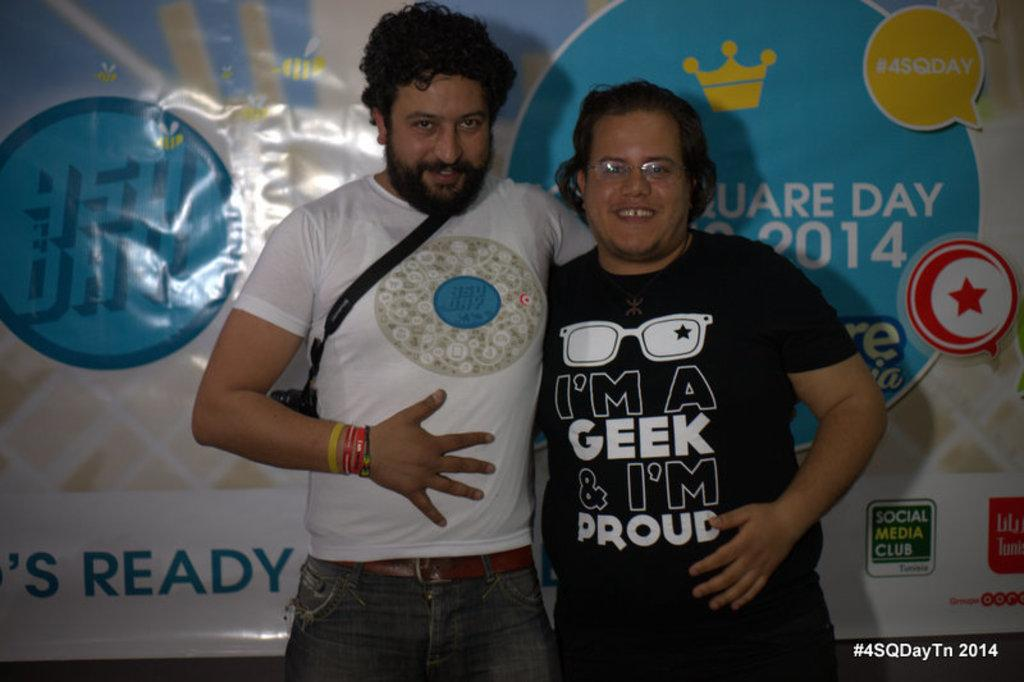How many people are in the image? There are two persons in the image. What are the persons doing in the image? The persons are smiling and standing. Is there any text or marking on the image? Yes, there is a watermark on the bottom right of the image. What can be seen in the background of the image? There is a banner in the background of the image. What type of pain is the person on the left experiencing in the image? There is no indication of pain in the image; both persons are smiling. What color is the eye of the person on the right in the image? There is no visible eye in the image, as both persons are facing forward and smiling. 